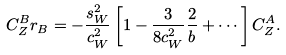Convert formula to latex. <formula><loc_0><loc_0><loc_500><loc_500>C _ { Z } ^ { B } r _ { B } = - \frac { s _ { W } ^ { 2 } } { c _ { W } ^ { 2 } } \left [ 1 - \frac { 3 } { 8 c _ { W } ^ { 2 } } \frac { 2 } { b } + \cdots \right ] C _ { Z } ^ { A } .</formula> 